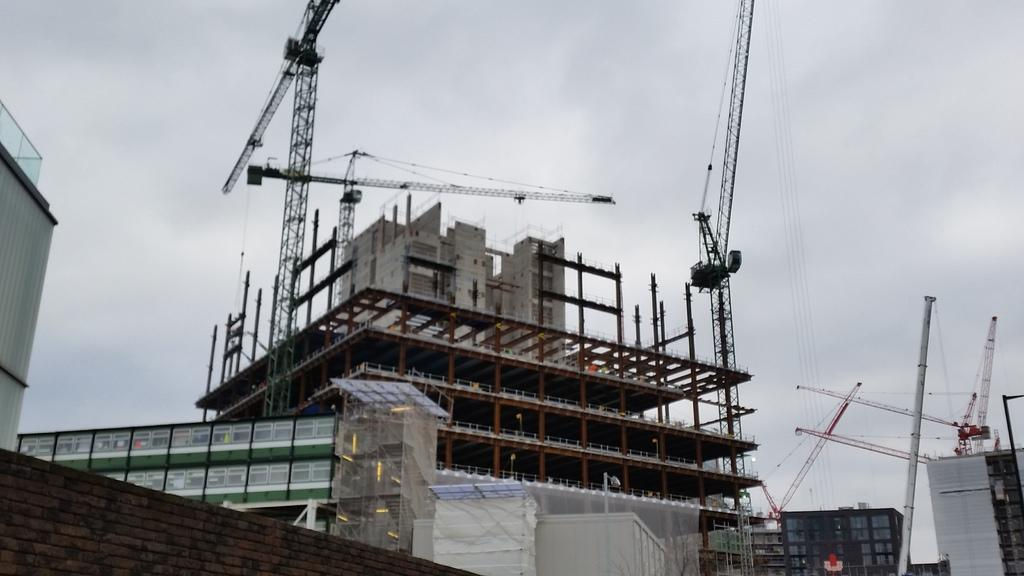What type of structure is being constructed in the image? There is a semi-constructed building in the image. Where are the towers located in the image? The towers are in the center of the image. What other structures can be seen in the image? There are other buildings in the image. What type of shelf is visible in the image? There is no shelf present in the image. What type of system is being used to construct the building in the image? The image does not provide information about the construction system being used. 